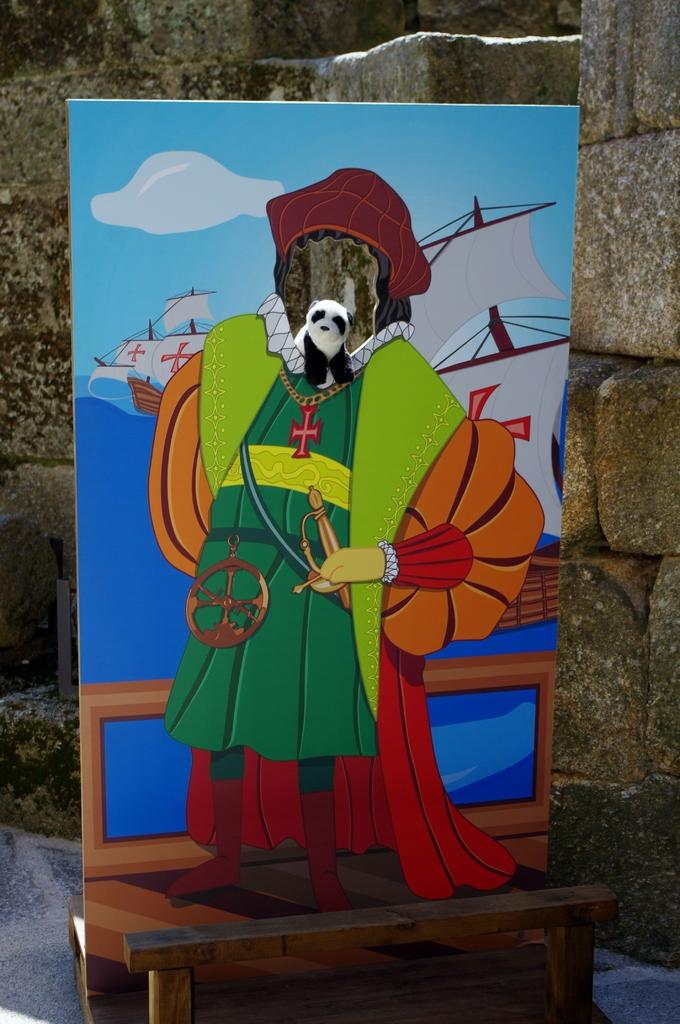What is the main object in the middle of the image? There is a banner in the middle of the image. What is behind the banner in the image? There is a wall behind the banner. How many kittens are playing baseball on the wall behind the banner? There are no kittens or baseball depicted in the image; it only features a banner and a wall. 